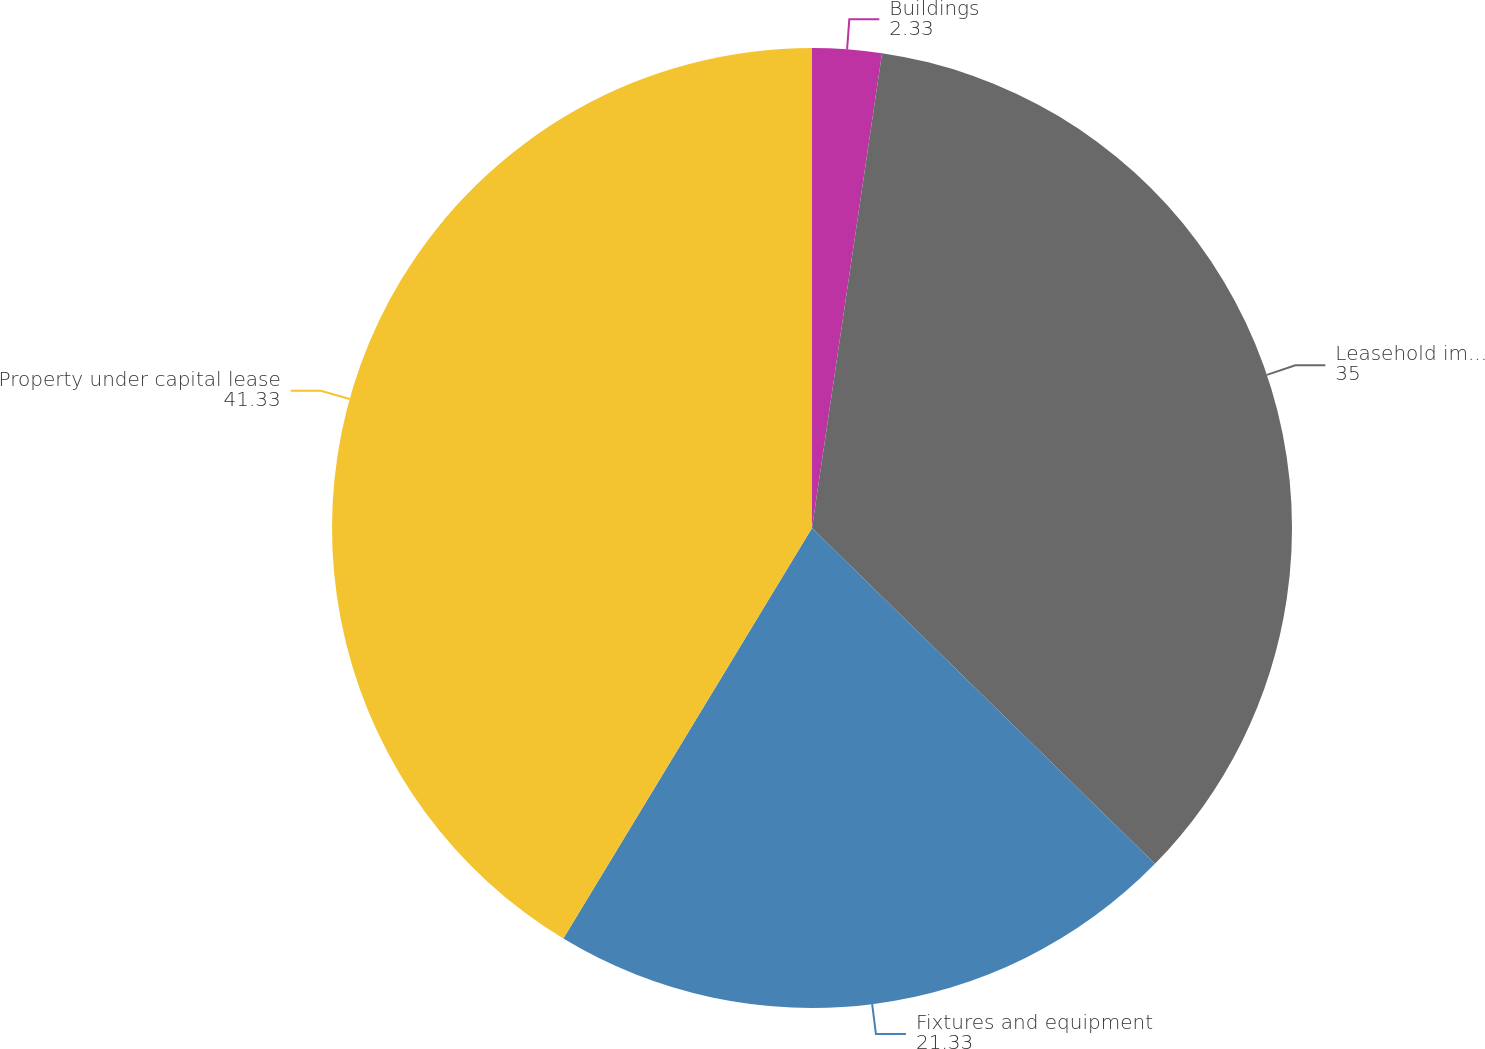Convert chart to OTSL. <chart><loc_0><loc_0><loc_500><loc_500><pie_chart><fcel>Buildings<fcel>Leasehold improvements<fcel>Fixtures and equipment<fcel>Property under capital lease<nl><fcel>2.33%<fcel>35.0%<fcel>21.33%<fcel>41.33%<nl></chart> 